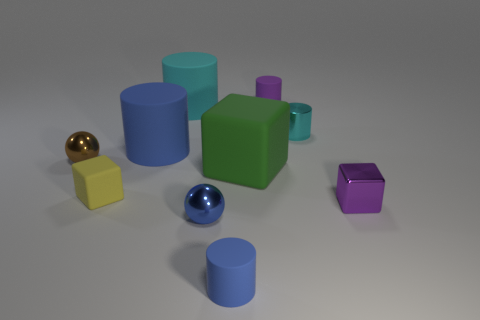Is there any significance to the arrangement of the shapes in the picture? The arrangement of shapes might not have a specific significance beyond aesthetic composition and demonstration of 3D rendering capabilities. The varied shapes and colors can create visual interest and are often used in test renders to demonstrate how different geometries and materials respond to a particular lighting environment. 